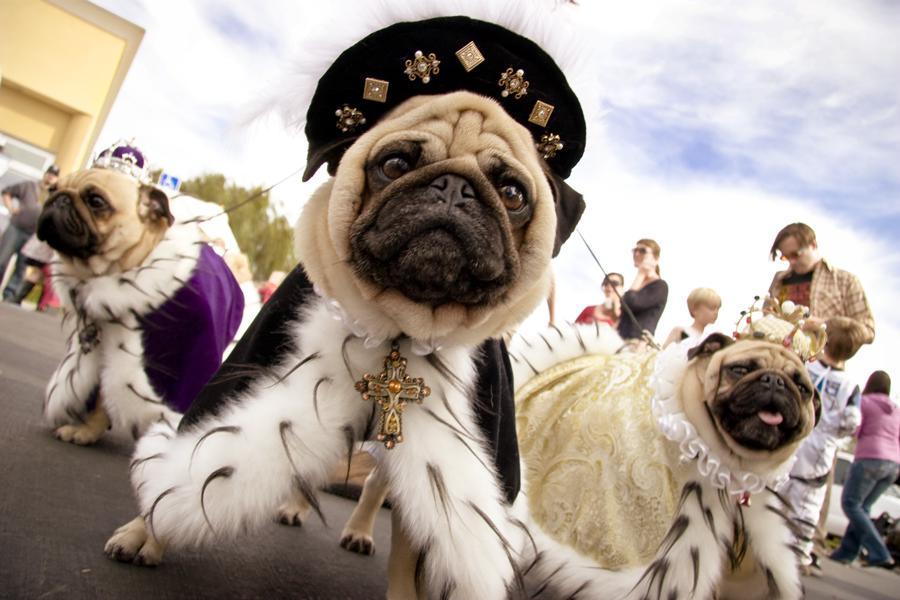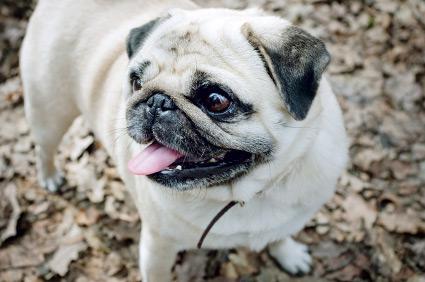The first image is the image on the left, the second image is the image on the right. Evaluate the accuracy of this statement regarding the images: "There are exactly three dogs in the right image.". Is it true? Answer yes or no. No. The first image is the image on the left, the second image is the image on the right. Analyze the images presented: Is the assertion "An image features three pugs in costumes that include fur trimming." valid? Answer yes or no. Yes. 